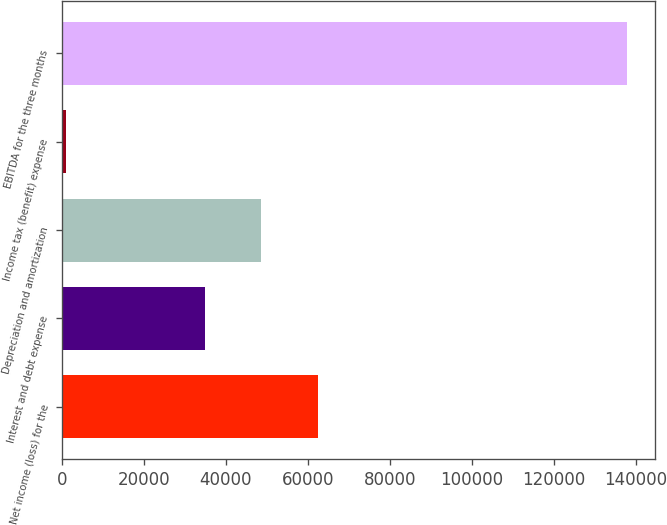Convert chart to OTSL. <chart><loc_0><loc_0><loc_500><loc_500><bar_chart><fcel>Net income (loss) for the<fcel>Interest and debt expense<fcel>Depreciation and amortization<fcel>Income tax (benefit) expense<fcel>EBITDA for the three months<nl><fcel>62389<fcel>34853<fcel>48531.5<fcel>952<fcel>137737<nl></chart> 